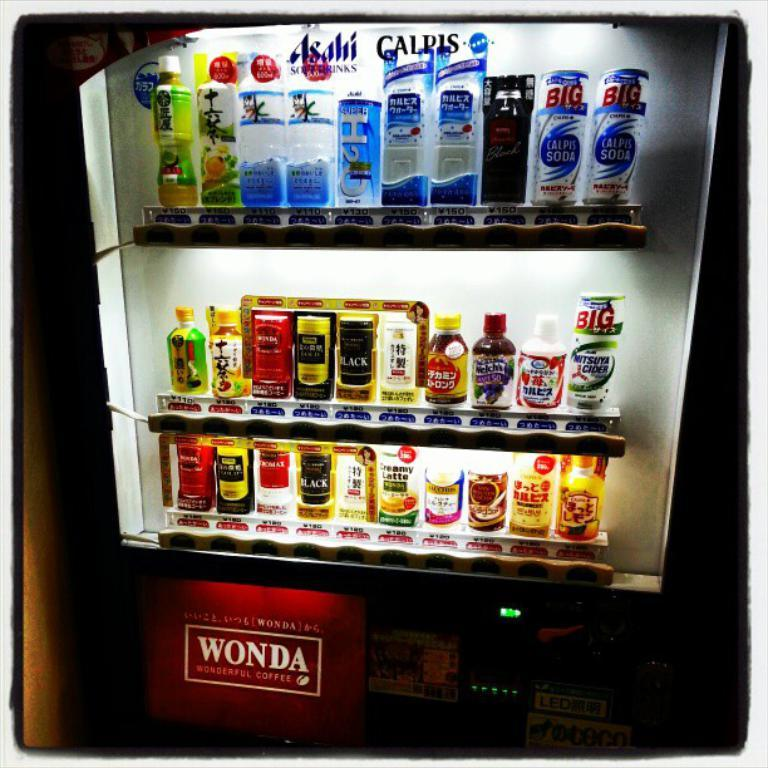<image>
Provide a brief description of the given image. a wonda refridgerator filled with different types of drinks 